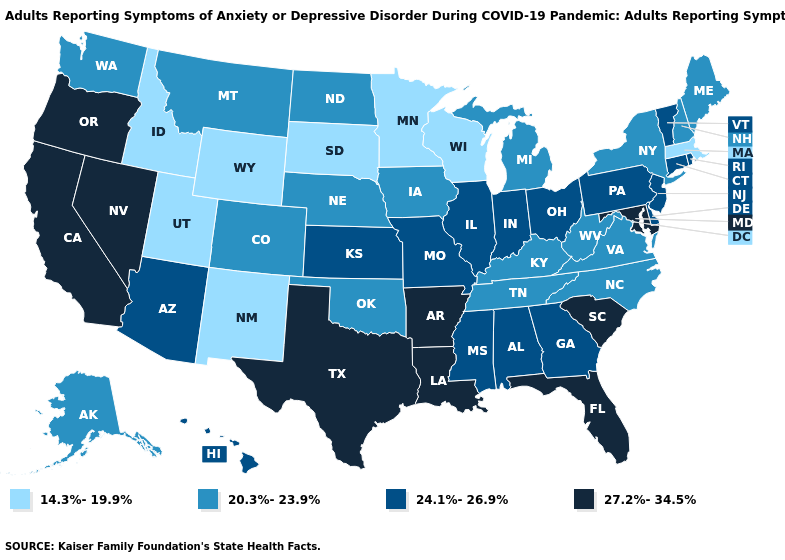What is the value of Arizona?
Give a very brief answer. 24.1%-26.9%. Does Iowa have the same value as Louisiana?
Short answer required. No. What is the highest value in states that border Arkansas?
Write a very short answer. 27.2%-34.5%. Does Illinois have the lowest value in the MidWest?
Short answer required. No. Does Rhode Island have a lower value than Idaho?
Quick response, please. No. Which states have the lowest value in the USA?
Be succinct. Idaho, Massachusetts, Minnesota, New Mexico, South Dakota, Utah, Wisconsin, Wyoming. How many symbols are there in the legend?
Concise answer only. 4. Which states have the highest value in the USA?
Give a very brief answer. Arkansas, California, Florida, Louisiana, Maryland, Nevada, Oregon, South Carolina, Texas. Does New Mexico have the highest value in the West?
Give a very brief answer. No. Among the states that border Tennessee , which have the highest value?
Write a very short answer. Arkansas. What is the highest value in the Northeast ?
Write a very short answer. 24.1%-26.9%. Name the states that have a value in the range 27.2%-34.5%?
Short answer required. Arkansas, California, Florida, Louisiana, Maryland, Nevada, Oregon, South Carolina, Texas. What is the lowest value in states that border Vermont?
Be succinct. 14.3%-19.9%. Name the states that have a value in the range 14.3%-19.9%?
Answer briefly. Idaho, Massachusetts, Minnesota, New Mexico, South Dakota, Utah, Wisconsin, Wyoming. Among the states that border Illinois , which have the highest value?
Be succinct. Indiana, Missouri. 